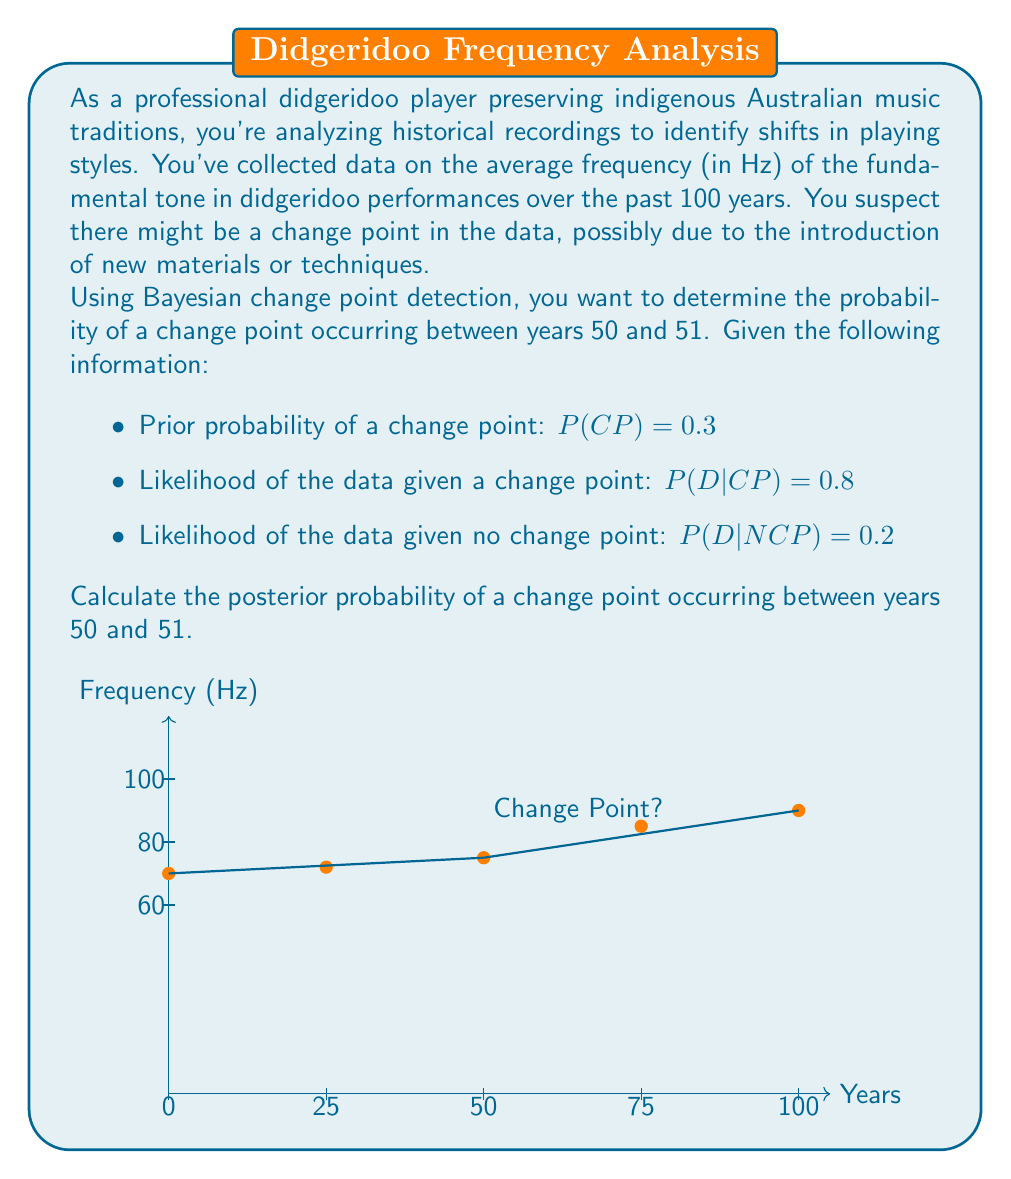Provide a solution to this math problem. To solve this problem, we'll use Bayes' theorem to calculate the posterior probability of a change point (CP) given the data (D). The formula for Bayes' theorem is:

$$P(CP|D) = \frac{P(D|CP) \cdot P(CP)}{P(D)}$$

We're given:
- $P(CP) = 0.3$ (prior probability of a change point)
- $P(D|CP) = 0.8$ (likelihood of the data given a change point)
- $P(D|NCP) = 0.2$ (likelihood of the data given no change point)

Step 1: Calculate $P(D)$ using the law of total probability:
$$P(D) = P(D|CP) \cdot P(CP) + P(D|NCP) \cdot P(NCP)$$
$$P(D) = 0.8 \cdot 0.3 + 0.2 \cdot (1-0.3)$$
$$P(D) = 0.24 + 0.14 = 0.38$$

Step 2: Apply Bayes' theorem:
$$P(CP|D) = \frac{P(D|CP) \cdot P(CP)}{P(D)}$$
$$P(CP|D) = \frac{0.8 \cdot 0.3}{0.38}$$
$$P(CP|D) = \frac{0.24}{0.38}$$
$$P(CP|D) \approx 0.6316$$

Therefore, the posterior probability of a change point occurring between years 50 and 51 is approximately 0.6316 or 63.16%.
Answer: $0.6316$ (or $63.16\%$) 